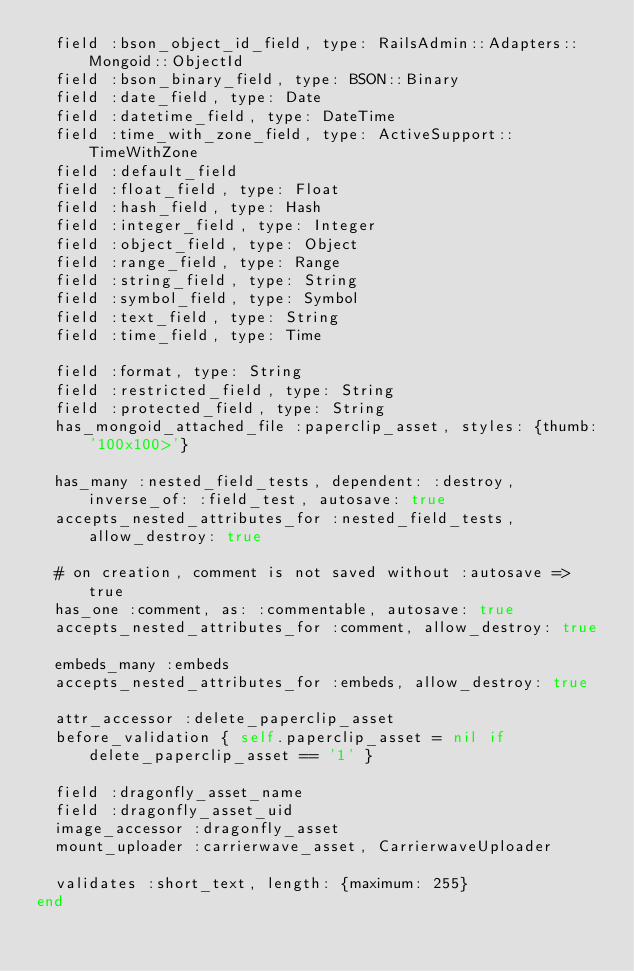<code> <loc_0><loc_0><loc_500><loc_500><_Ruby_>  field :bson_object_id_field, type: RailsAdmin::Adapters::Mongoid::ObjectId
  field :bson_binary_field, type: BSON::Binary
  field :date_field, type: Date
  field :datetime_field, type: DateTime
  field :time_with_zone_field, type: ActiveSupport::TimeWithZone
  field :default_field
  field :float_field, type: Float
  field :hash_field, type: Hash
  field :integer_field, type: Integer
  field :object_field, type: Object
  field :range_field, type: Range
  field :string_field, type: String
  field :symbol_field, type: Symbol
  field :text_field, type: String
  field :time_field, type: Time

  field :format, type: String
  field :restricted_field, type: String
  field :protected_field, type: String
  has_mongoid_attached_file :paperclip_asset, styles: {thumb: '100x100>'}

  has_many :nested_field_tests, dependent: :destroy, inverse_of: :field_test, autosave: true
  accepts_nested_attributes_for :nested_field_tests, allow_destroy: true

  # on creation, comment is not saved without :autosave => true
  has_one :comment, as: :commentable, autosave: true
  accepts_nested_attributes_for :comment, allow_destroy: true

  embeds_many :embeds
  accepts_nested_attributes_for :embeds, allow_destroy: true

  attr_accessor :delete_paperclip_asset
  before_validation { self.paperclip_asset = nil if delete_paperclip_asset == '1' }

  field :dragonfly_asset_name
  field :dragonfly_asset_uid
  image_accessor :dragonfly_asset
  mount_uploader :carrierwave_asset, CarrierwaveUploader

  validates :short_text, length: {maximum: 255}
end
</code> 